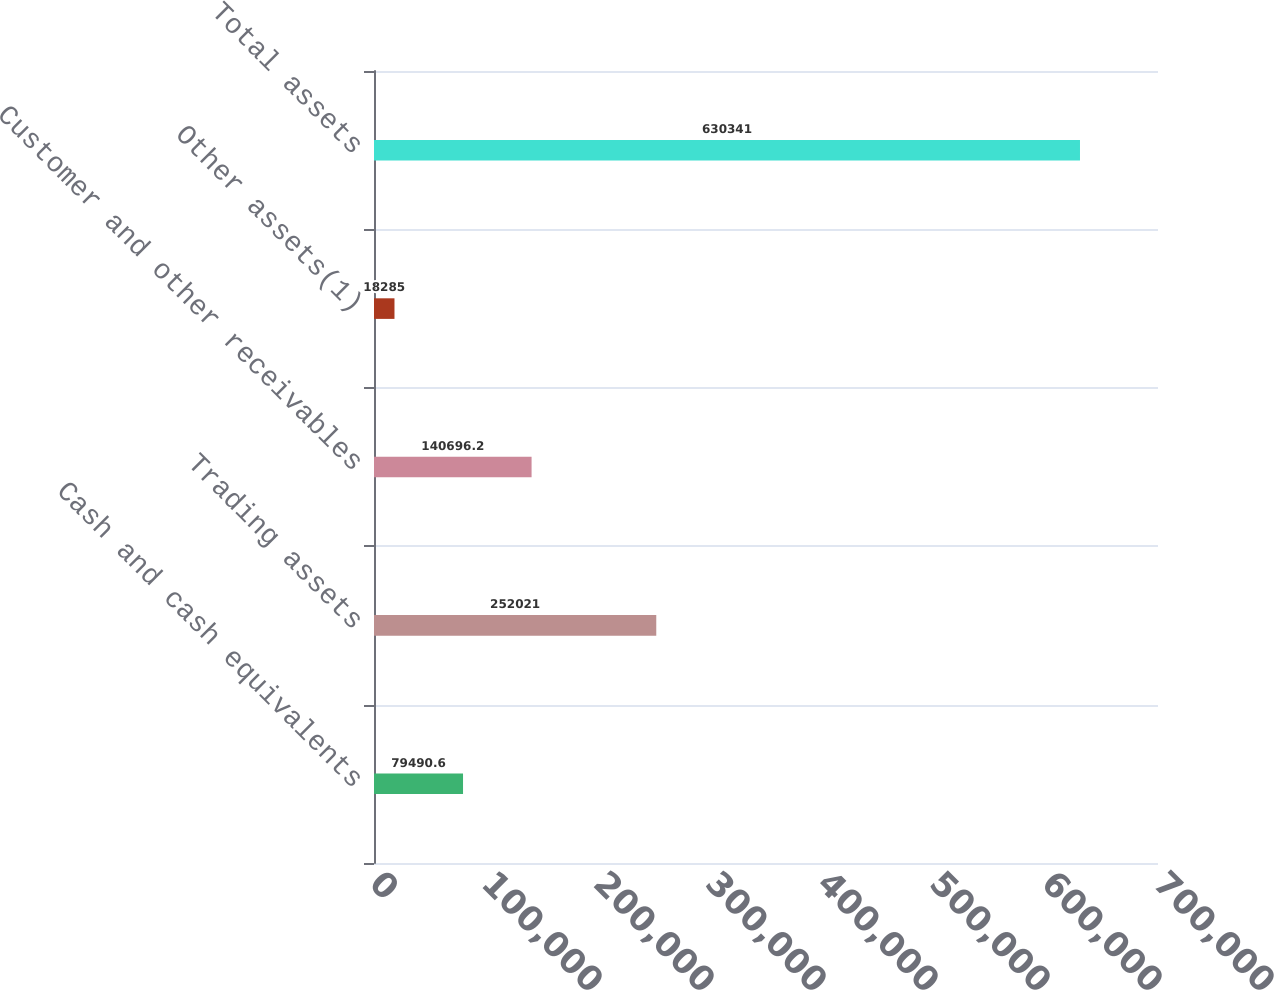Convert chart. <chart><loc_0><loc_0><loc_500><loc_500><bar_chart><fcel>Cash and cash equivalents<fcel>Trading assets<fcel>Customer and other receivables<fcel>Other assets(1)<fcel>Total assets<nl><fcel>79490.6<fcel>252021<fcel>140696<fcel>18285<fcel>630341<nl></chart> 